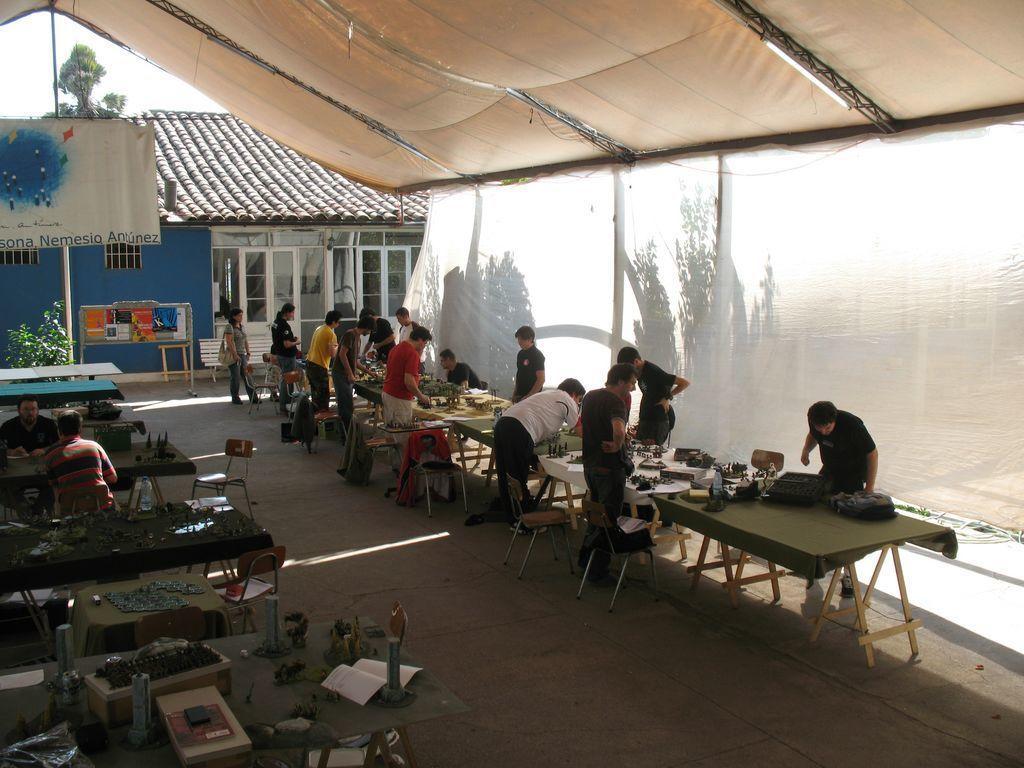How would you summarize this image in a sentence or two? In this picture there are few people sitting on the chair and few people standing. There are few objects on the table. There is a woman wearing a bag. There is a house. There is a bench and a plant. There is a tree at the background There is a tent. 